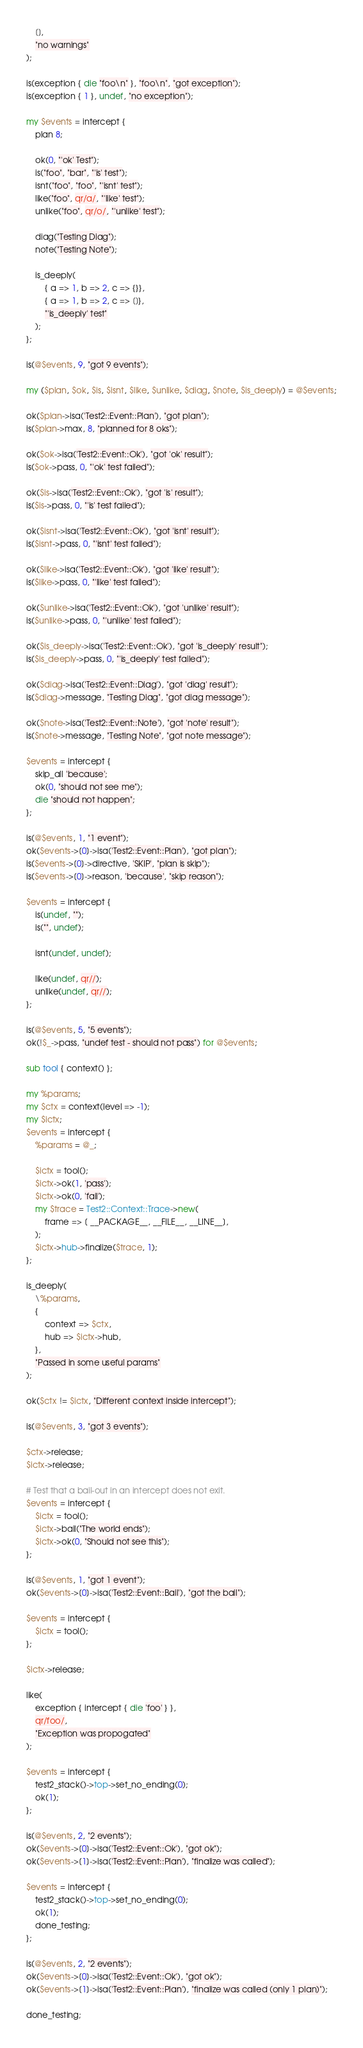<code> <loc_0><loc_0><loc_500><loc_500><_Perl_>    [],
    "no warnings"
);

is(exception { die "foo\n" }, "foo\n", "got exception");
is(exception { 1 }, undef, "no exception");

my $events = intercept {
    plan 8;

    ok(0, "'ok' Test");
    is("foo", "bar", "'is' test");
    isnt("foo", "foo", "'isnt' test");
    like("foo", qr/a/, "'like' test");
    unlike("foo", qr/o/, "'unlike' test");

    diag("Testing Diag");
    note("Testing Note");

    is_deeply(
        { a => 1, b => 2, c => {}},
        { a => 1, b => 2, c => []},
        "'is_deeply' test"
    );
};

is(@$events, 9, "got 9 events");

my ($plan, $ok, $is, $isnt, $like, $unlike, $diag, $note, $is_deeply) = @$events;

ok($plan->isa('Test2::Event::Plan'), "got plan");
is($plan->max, 8, "planned for 8 oks");

ok($ok->isa('Test2::Event::Ok'), "got 'ok' result");
is($ok->pass, 0, "'ok' test failed");

ok($is->isa('Test2::Event::Ok'), "got 'is' result");
is($is->pass, 0, "'is' test failed");

ok($isnt->isa('Test2::Event::Ok'), "got 'isnt' result");
is($isnt->pass, 0, "'isnt' test failed");

ok($like->isa('Test2::Event::Ok'), "got 'like' result");
is($like->pass, 0, "'like' test failed");

ok($unlike->isa('Test2::Event::Ok'), "got 'unlike' result");
is($unlike->pass, 0, "'unlike' test failed");

ok($is_deeply->isa('Test2::Event::Ok'), "got 'is_deeply' result");
is($is_deeply->pass, 0, "'is_deeply' test failed");

ok($diag->isa('Test2::Event::Diag'), "got 'diag' result");
is($diag->message, "Testing Diag", "got diag message");

ok($note->isa('Test2::Event::Note'), "got 'note' result");
is($note->message, "Testing Note", "got note message");

$events = intercept {
    skip_all 'because';
    ok(0, "should not see me");
    die "should not happen";
};

is(@$events, 1, "1 event");
ok($events->[0]->isa('Test2::Event::Plan'), "got plan");
is($events->[0]->directive, 'SKIP', "plan is skip");
is($events->[0]->reason, 'because', "skip reason");

$events = intercept {
    is(undef, "");
    is("", undef);

    isnt(undef, undef);

    like(undef, qr//);
    unlike(undef, qr//);
};

is(@$events, 5, "5 events");
ok(!$_->pass, "undef test - should not pass") for @$events;

sub tool { context() };

my %params;
my $ctx = context(level => -1);
my $ictx;
$events = intercept {
    %params = @_;

    $ictx = tool();
    $ictx->ok(1, 'pass');
    $ictx->ok(0, 'fail');
    my $trace = Test2::Context::Trace->new(
        frame => [ __PACKAGE__, __FILE__, __LINE__],
    );
    $ictx->hub->finalize($trace, 1);
};

is_deeply(
    \%params,
    {
        context => $ctx,
        hub => $ictx->hub,
    },
    "Passed in some useful params"
);

ok($ctx != $ictx, "Different context inside intercept");

is(@$events, 3, "got 3 events");

$ctx->release;
$ictx->release;

# Test that a bail-out in an intercept does not exit.
$events = intercept {
    $ictx = tool();
    $ictx->bail("The world ends");
    $ictx->ok(0, "Should not see this");
};

is(@$events, 1, "got 1 event");
ok($events->[0]->isa('Test2::Event::Bail'), "got the bail");

$events = intercept {
    $ictx = tool();
};

$ictx->release;

like(
    exception { intercept { die 'foo' } },
    qr/foo/,
    "Exception was propogated"
);

$events = intercept {
    test2_stack()->top->set_no_ending(0);
    ok(1);
};

is(@$events, 2, "2 events");
ok($events->[0]->isa('Test2::Event::Ok'), "got ok");
ok($events->[1]->isa('Test2::Event::Plan'), "finalize was called");

$events = intercept {
    test2_stack()->top->set_no_ending(0);
    ok(1);
    done_testing;
};

is(@$events, 2, "2 events");
ok($events->[0]->isa('Test2::Event::Ok'), "got ok");
ok($events->[1]->isa('Test2::Event::Plan'), "finalize was called (only 1 plan)");

done_testing;
</code> 